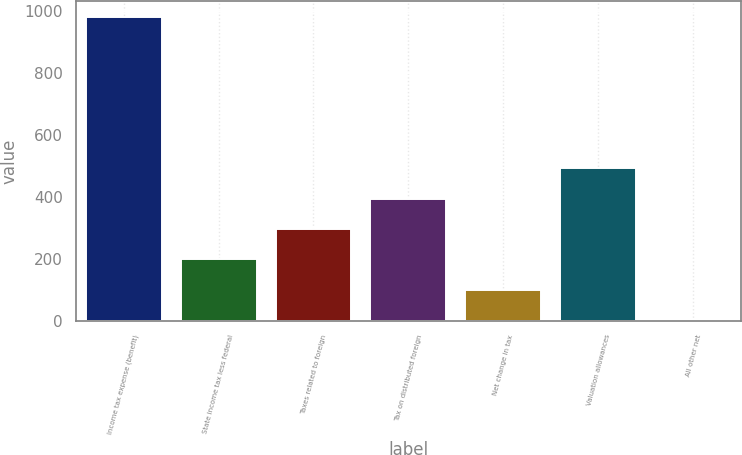Convert chart. <chart><loc_0><loc_0><loc_500><loc_500><bar_chart><fcel>Income tax expense (benefit)<fcel>State income tax less federal<fcel>Taxes related to foreign<fcel>Tax on distributed foreign<fcel>Net change in tax<fcel>Valuation allowances<fcel>All other net<nl><fcel>983<fcel>198.2<fcel>296.3<fcel>394.4<fcel>100.1<fcel>492.5<fcel>2<nl></chart> 